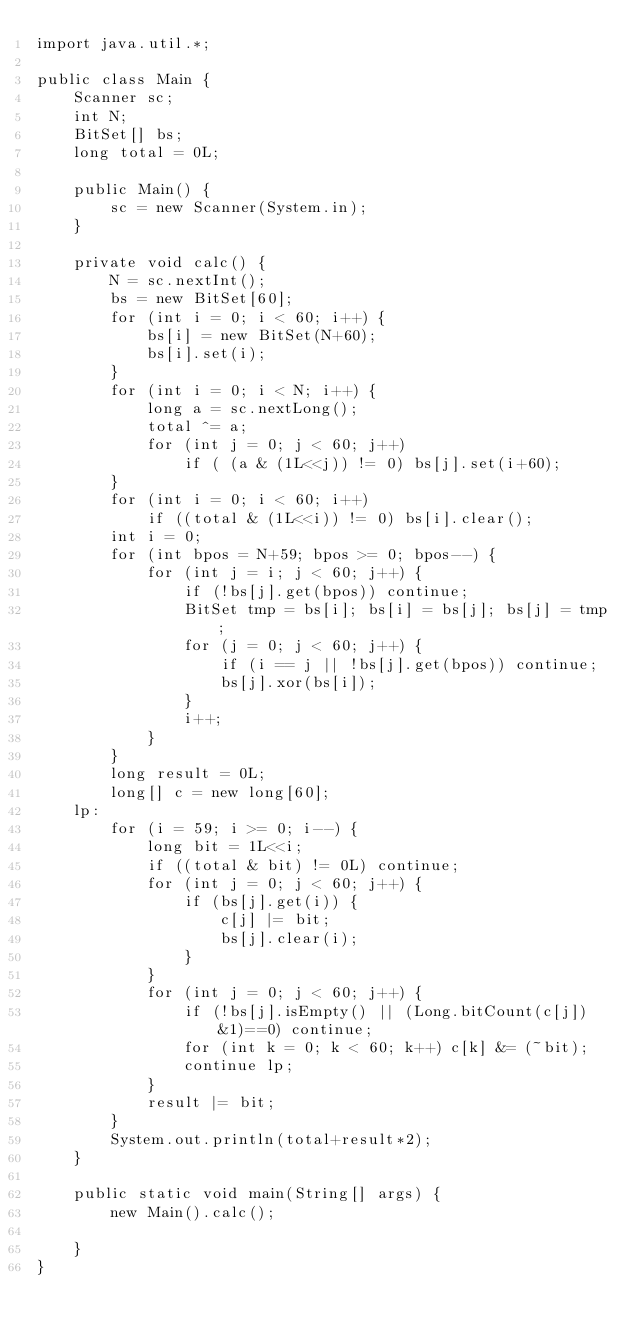<code> <loc_0><loc_0><loc_500><loc_500><_Java_>import java.util.*;

public class Main {
	Scanner sc;
	int N;
	BitSet[] bs;
	long total = 0L;
	
	public Main() {
		sc = new Scanner(System.in);
	}
	
	private void calc() {
		N = sc.nextInt();
		bs = new BitSet[60];
		for (int i = 0; i < 60; i++) {
			bs[i] = new BitSet(N+60);
			bs[i].set(i);
		}
		for (int i = 0; i < N; i++) {
			long a = sc.nextLong();
			total ^= a;
			for (int j = 0; j < 60; j++)
				if ( (a & (1L<<j)) != 0) bs[j].set(i+60);
		}
		for (int i = 0; i < 60; i++)
			if ((total & (1L<<i)) != 0) bs[i].clear();
		int i = 0;
		for (int bpos = N+59; bpos >= 0; bpos--) {
			for (int j = i; j < 60; j++) {
				if (!bs[j].get(bpos)) continue;
				BitSet tmp = bs[i]; bs[i] = bs[j]; bs[j] = tmp;
				for (j = 0; j < 60; j++) {
					if (i == j || !bs[j].get(bpos)) continue;
					bs[j].xor(bs[i]);
				}
				i++;
			}
		}
		long result = 0L;
		long[] c = new long[60];
	lp:
		for (i = 59; i >= 0; i--) {
			long bit = 1L<<i;
			if ((total & bit) != 0L) continue;
			for (int j = 0; j < 60; j++) {
				if (bs[j].get(i)) {
					c[j] |= bit;
					bs[j].clear(i);
				}
			}
			for (int j = 0; j < 60; j++) {
				if (!bs[j].isEmpty() || (Long.bitCount(c[j])&1)==0) continue;
				for (int k = 0; k < 60; k++) c[k] &= (~bit);
				continue lp;
			}
			result |= bit;
		}
		System.out.println(total+result*2);
	}
	
	public static void main(String[] args) {
		new Main().calc();
		
	}
}
</code> 